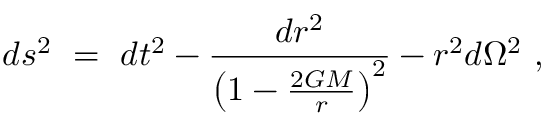Convert formula to latex. <formula><loc_0><loc_0><loc_500><loc_500>d s ^ { 2 } = d t ^ { 2 } - \frac { d r ^ { 2 } } { \left ( 1 - \frac { 2 G M } { r } \right ) ^ { 2 } } - r ^ { 2 } d \Omega ^ { 2 } ,</formula> 